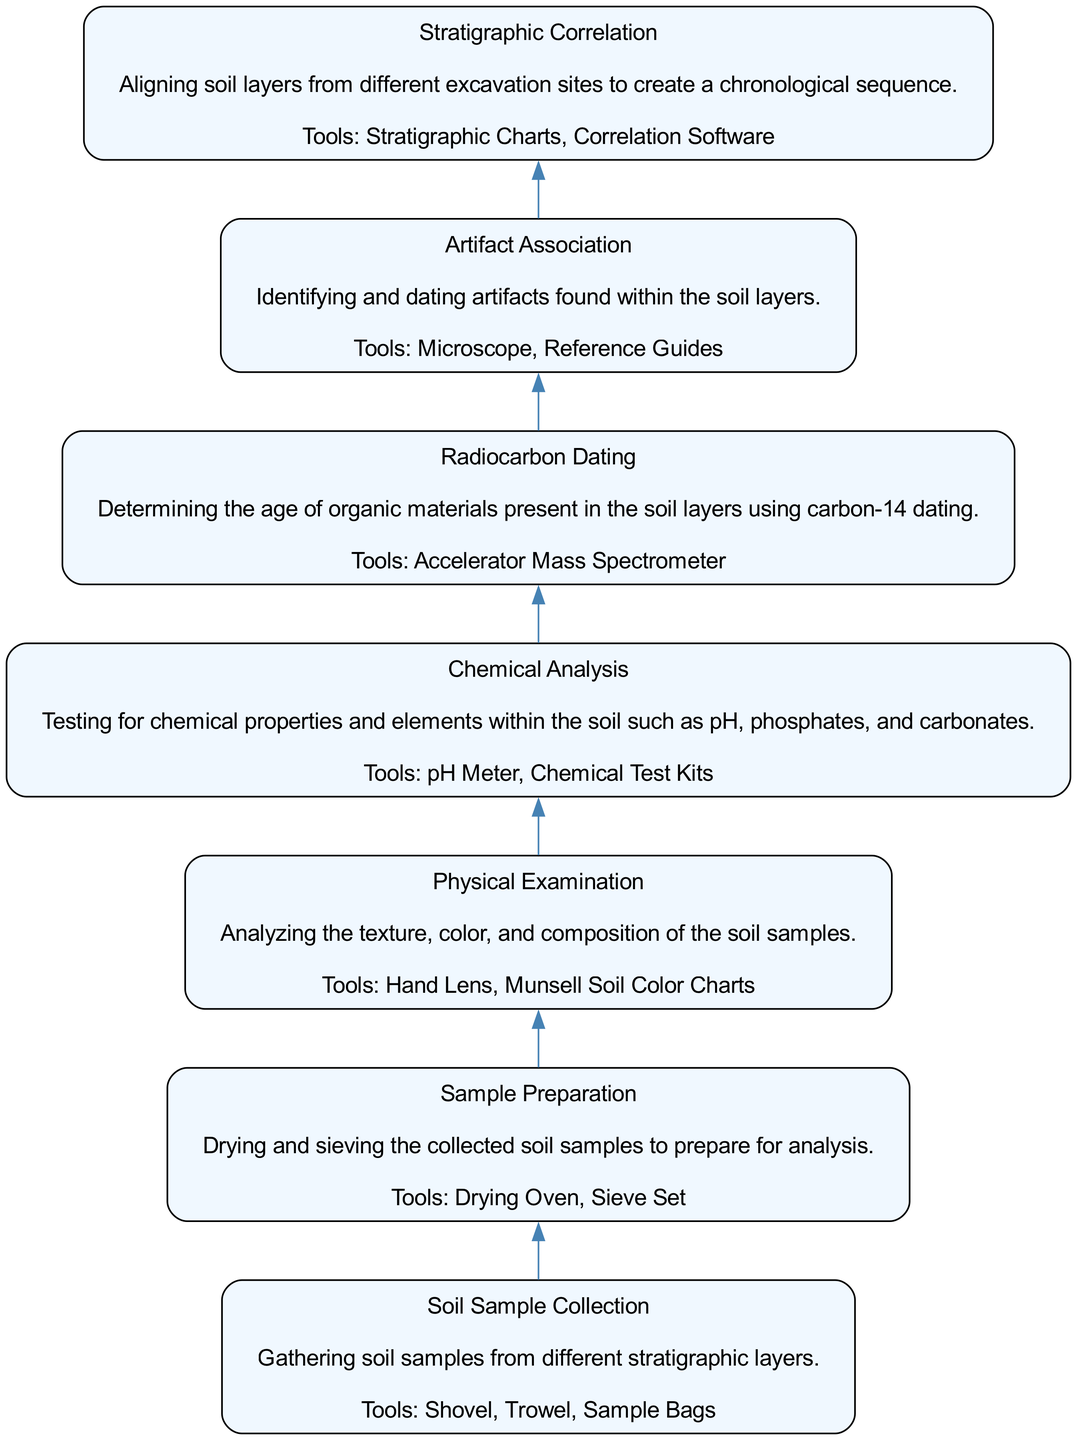What is the first step in the flow of the diagram? The first step, located at the bottom of the diagram, is "Soil Sample Collection." It is the starting point of the processes illustrated.
Answer: Soil Sample Collection How many total nodes are in the diagram? By counting each individual step represented as a node, we find there are seven nodes in total ranging from soil sample collection to stratigraphic correlation.
Answer: 7 Which tool is associated with "Chemical Analysis"? The node for "Chemical Analysis" mentions "pH Meter" and "Chemical Test Kits" as related tools, highlighting the specific instruments needed for this step.
Answer: pH Meter, Chemical Test Kits What follows after "Physical Examination" in the flow? The diagram indicates that immediately after "Physical Examination," the next step is "Chemical Analysis," indicating the sequential nature of both processes.
Answer: Chemical Analysis What is the last step in the flow of the diagram? At the top of the diagram, the final step is "Stratigraphic Correlation," which denotes the last process of analyzing the soil layers before concluding the study.
Answer: Stratigraphic Correlation How are "Artifact Association" and "Radiocarbon Dating" related? Both "Artifact Association" and "Radiocarbon Dating" are crucial steps in understanding the historical context of the findings, but "Artifact Association" directly links the dating of artifacts to the layers identified by the previous analyses.
Answer: They inform each other about the dating and historical context What tools are needed for the "Soil Sample Collection"? According to the node for "Soil Sample Collection," the tools required include "Shovel," "Trowel," and "Sample Bags," which are critical for gathering soil samples.
Answer: Shovel, Trowel, Sample Bags Which step involves analyzing chemical properties? In the diagram, "Chemical Analysis" is the step specifically dedicated to testing for chemical properties and elements within the soil samples, detailing its focus on these aspects.
Answer: Chemical Analysis Which node focuses on creating a chronological sequence? The node "Stratigraphic Correlation" is dedicated to aligning soil layers from different excavation sites, marking its emphasis on establishing a chronological timeline of the layers.
Answer: Stratigraphic Correlation 